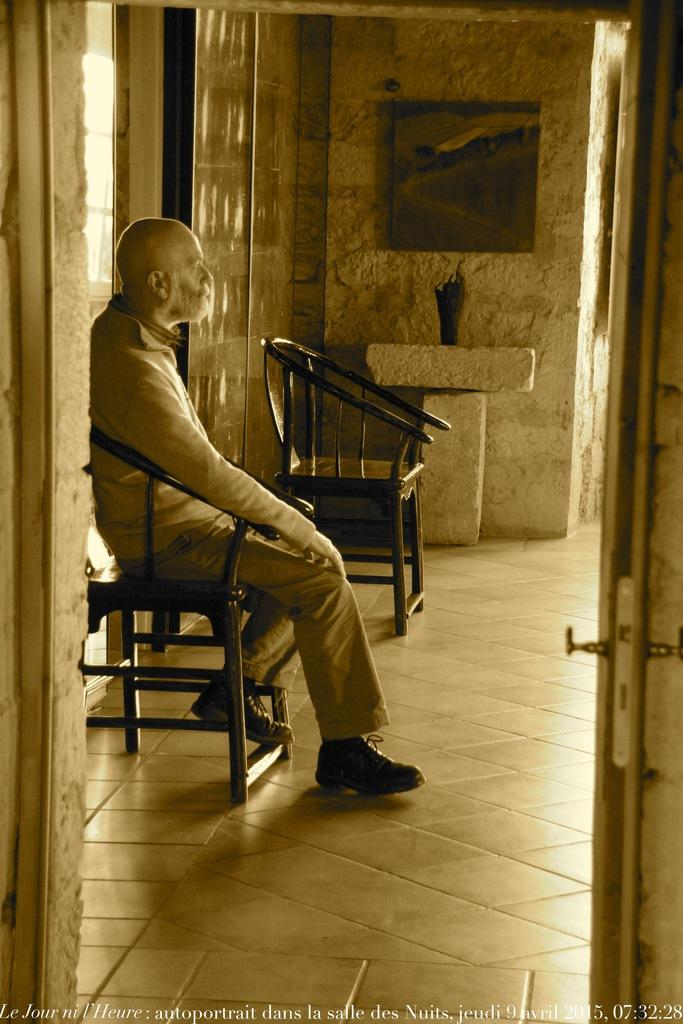What is the man in the image doing? The man is sitting on a chair in the image. Are there any other chairs visible in the image? Yes, there is another chair beside the man. What can be seen behind the man in the image? There is a wall visible in the image. Can you see a pig jumping over the wall in the image? No, there is no pig or jumping activity present in the image. 